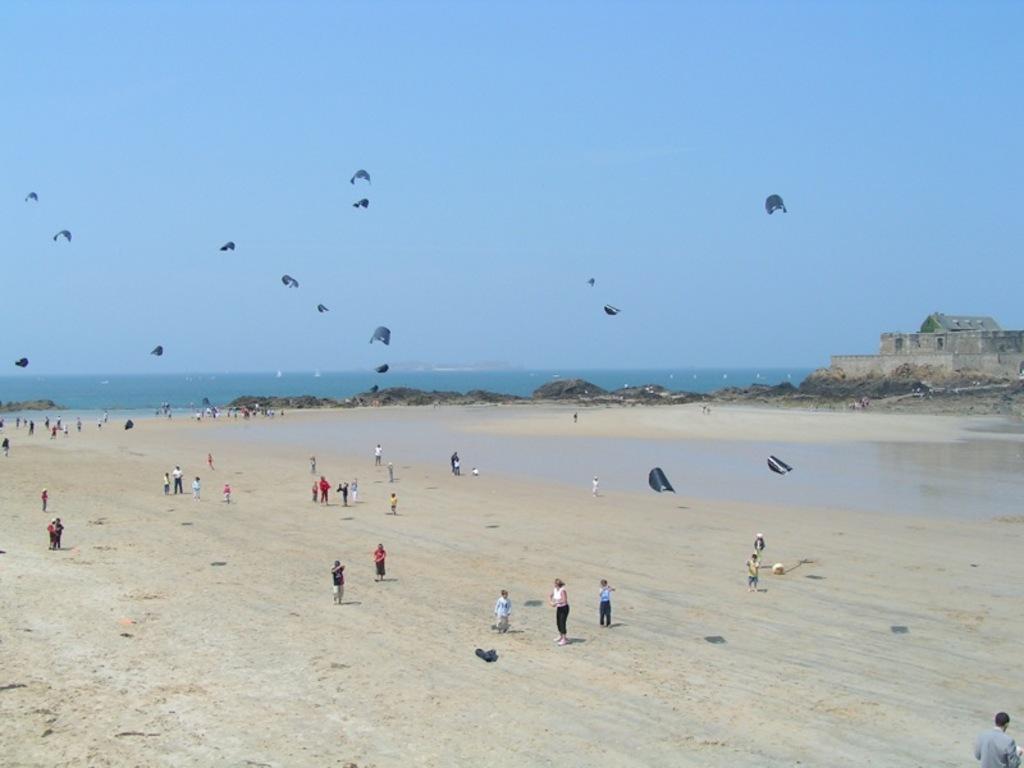In one or two sentences, can you explain what this image depicts? In the image we can see there are many people standing and some of them are walking, they are wearing clothes. We can even see there are kites in the sky. Here we can see the water, rocks, the house and the sky. 